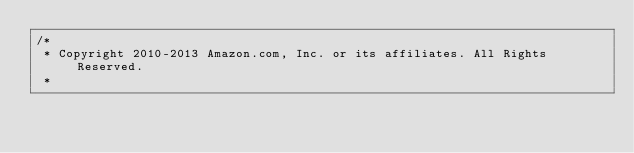Convert code to text. <code><loc_0><loc_0><loc_500><loc_500><_C#_>/*
 * Copyright 2010-2013 Amazon.com, Inc. or its affiliates. All Rights Reserved.
 * </code> 